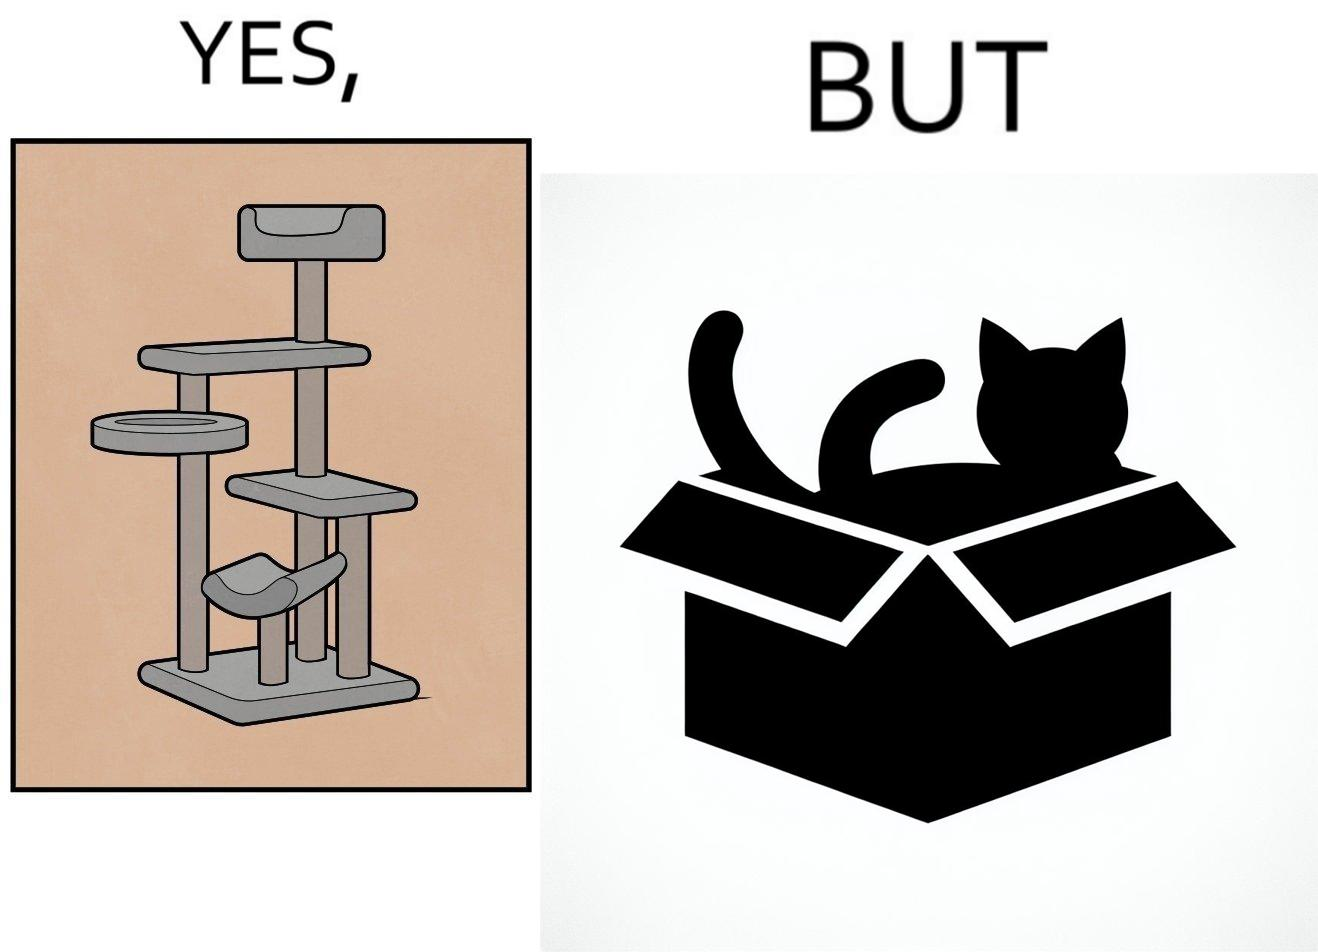Does this image contain satire or humor? Yes, this image is satirical. 